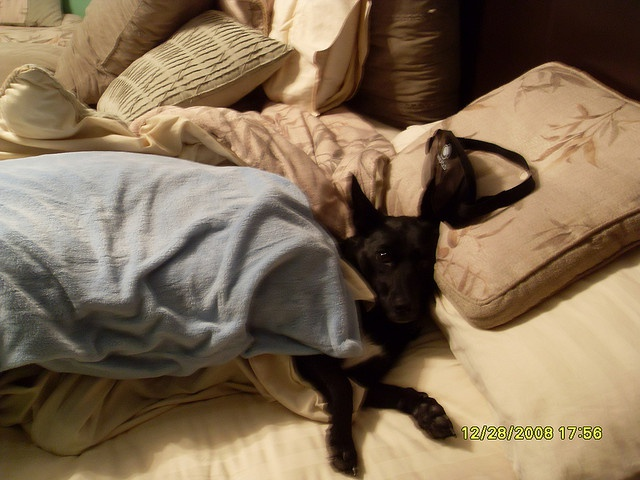Describe the objects in this image and their specific colors. I can see bed in black and tan tones, dog in tan, black, maroon, and gray tones, and handbag in tan, black, and maroon tones in this image. 